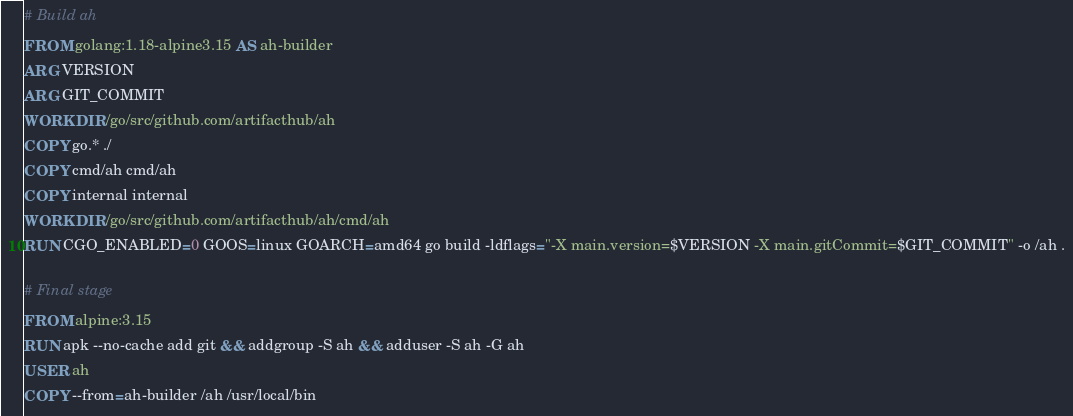<code> <loc_0><loc_0><loc_500><loc_500><_Dockerfile_># Build ah
FROM golang:1.18-alpine3.15 AS ah-builder
ARG VERSION
ARG GIT_COMMIT
WORKDIR /go/src/github.com/artifacthub/ah
COPY go.* ./
COPY cmd/ah cmd/ah
COPY internal internal
WORKDIR /go/src/github.com/artifacthub/ah/cmd/ah
RUN CGO_ENABLED=0 GOOS=linux GOARCH=amd64 go build -ldflags="-X main.version=$VERSION -X main.gitCommit=$GIT_COMMIT" -o /ah .

# Final stage
FROM alpine:3.15
RUN apk --no-cache add git && addgroup -S ah && adduser -S ah -G ah
USER ah
COPY --from=ah-builder /ah /usr/local/bin
</code> 